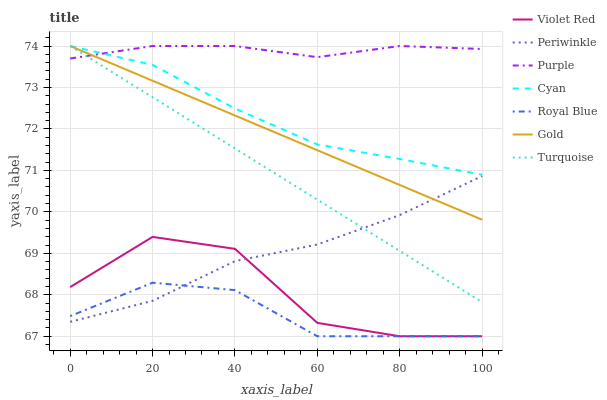Does Royal Blue have the minimum area under the curve?
Answer yes or no. Yes. Does Purple have the maximum area under the curve?
Answer yes or no. Yes. Does Gold have the minimum area under the curve?
Answer yes or no. No. Does Gold have the maximum area under the curve?
Answer yes or no. No. Is Turquoise the smoothest?
Answer yes or no. Yes. Is Violet Red the roughest?
Answer yes or no. Yes. Is Gold the smoothest?
Answer yes or no. No. Is Gold the roughest?
Answer yes or no. No. Does Violet Red have the lowest value?
Answer yes or no. Yes. Does Gold have the lowest value?
Answer yes or no. No. Does Cyan have the highest value?
Answer yes or no. Yes. Does Royal Blue have the highest value?
Answer yes or no. No. Is Royal Blue less than Gold?
Answer yes or no. Yes. Is Cyan greater than Periwinkle?
Answer yes or no. Yes. Does Royal Blue intersect Violet Red?
Answer yes or no. Yes. Is Royal Blue less than Violet Red?
Answer yes or no. No. Is Royal Blue greater than Violet Red?
Answer yes or no. No. Does Royal Blue intersect Gold?
Answer yes or no. No. 